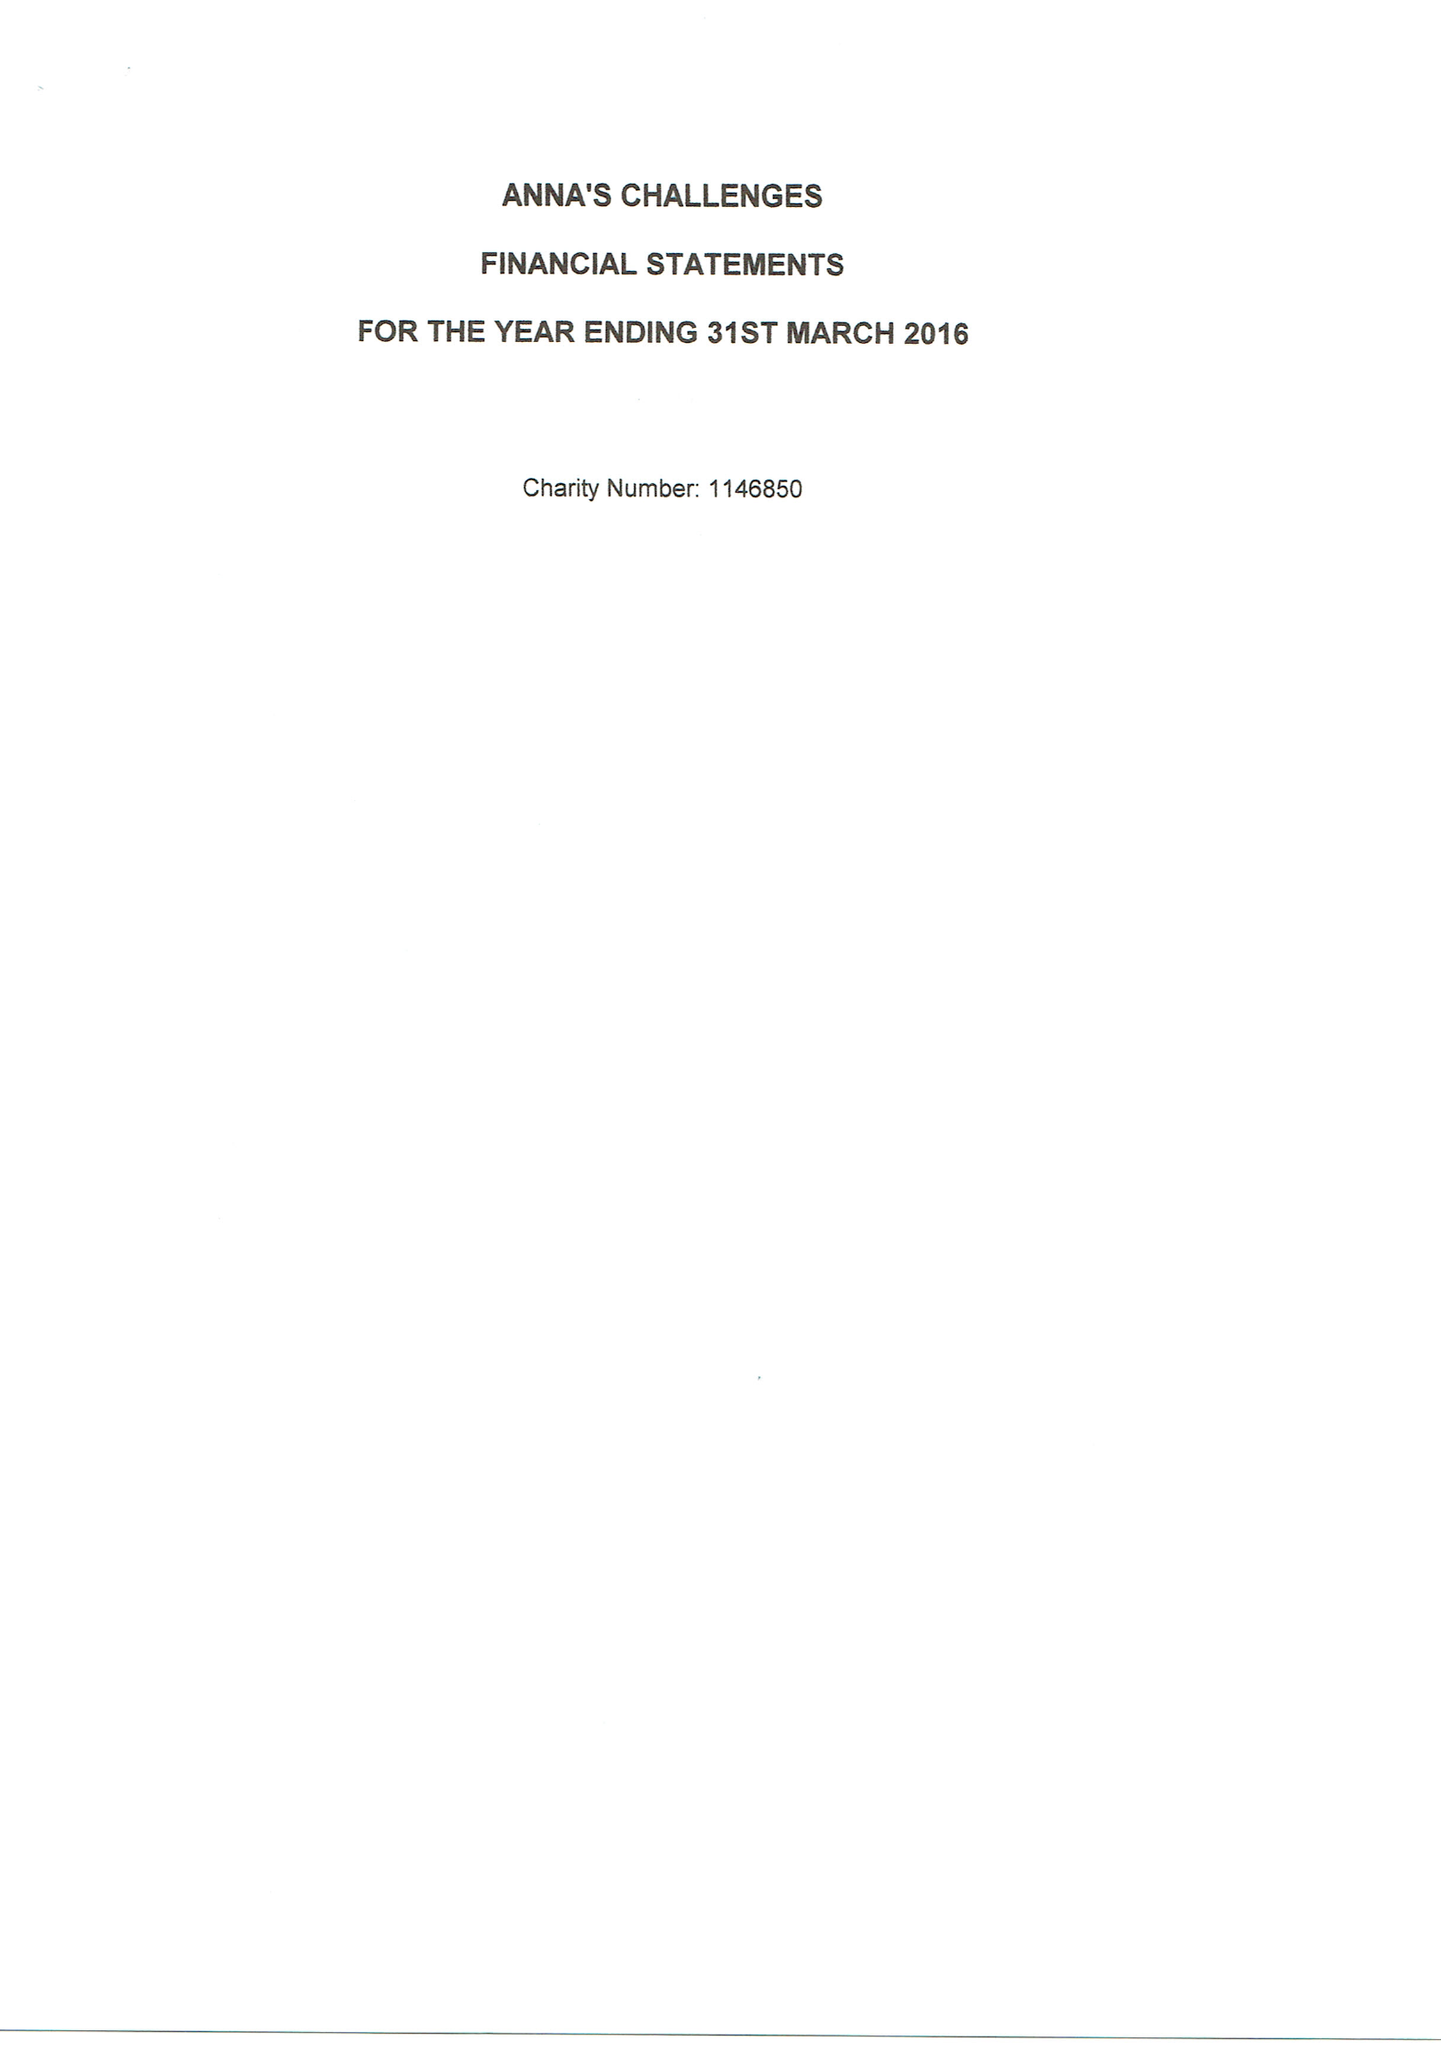What is the value for the charity_number?
Answer the question using a single word or phrase. 1146850 